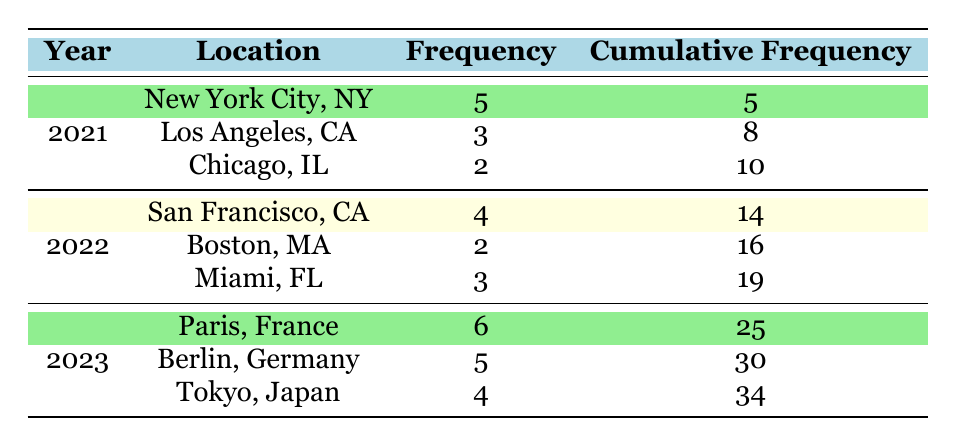What location had the highest frequency of art exhibitions in 2021? Referring to the data, New York City, NY has a frequency of 5, which is higher than Los Angeles, CA with 3 and Chicago, IL with 2. Therefore, New York City, NY had the highest frequency of art exhibitions in 2021.
Answer: New York City, NY How many art exhibitions were attended in total in 2022? For 2022, San Francisco, CA had 4, Boston, MA had 2, and Miami, FL had 3. Adding these frequencies together gives us 4 + 2 + 3 = 9. So, there were a total of 9 art exhibitions attended in 2022.
Answer: 9 Is it true that Paris had more art exhibitions than Los Angeles in 2023? The frequency for Paris, France in 2023 is 6, while Los Angeles, CA does not appear in the 2023 data. Therefore, since Paris had exhibitions and Los Angeles did not, the statement is true.
Answer: Yes What is the cumulative frequency of art exhibitions in 2021? The cumulative frequency for 2021 can be calculated by adding the frequencies for all locations within that year, which are 5 for New York City, NY; 3 for Los Angeles, CA; and 2 for Chicago, IL. Adding these gives us 5 + 3 + 2 = 10. The cumulative frequency of art exhibitions in 2021 is 10.
Answer: 10 Which year had the highest total frequency of art exhibitions? Calculating the total frequency per year, in 2021 there were 10 (5 + 3 + 2), in 2022 there were 9 (4 + 3 + 2), and in 2023 there were 15 (6 + 5 + 4). Since 15 (2023) is greater than both 10 (2021) and 9 (2022), 2023 had the highest total frequency of art exhibitions.
Answer: 2023 What is the average frequency of art exhibitions in 2023? To find the average frequency in 2023, we take the total frequency for the year which is 15 (6 for Paris + 5 for Berlin + 4 for Tokyo). There are 3 locations, so the average is 15 / 3 = 5. Therefore, the average frequency of art exhibitions in 2023 is 5.
Answer: 5 